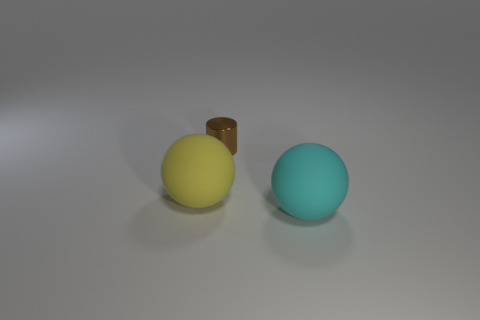Add 3 small brown shiny cylinders. How many objects exist? 6 Subtract all cyan balls. How many balls are left? 1 Subtract 1 cylinders. How many cylinders are left? 0 Subtract 1 brown cylinders. How many objects are left? 2 Subtract all spheres. How many objects are left? 1 Subtract all red cylinders. Subtract all cyan balls. How many cylinders are left? 1 Subtract all cyan blocks. How many yellow balls are left? 1 Subtract all yellow rubber things. Subtract all small metal things. How many objects are left? 1 Add 2 cyan things. How many cyan things are left? 3 Add 3 large cyan rubber spheres. How many large cyan rubber spheres exist? 4 